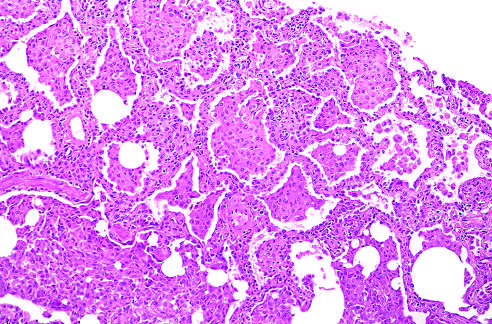s there accumulation of large numbers of macrophages within the alveolar spaces with only slight fibrous thickening of the alveolar walls?
Answer the question using a single word or phrase. Yes 